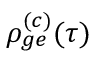Convert formula to latex. <formula><loc_0><loc_0><loc_500><loc_500>\rho _ { g e } ^ { ( c ) } ( \tau )</formula> 